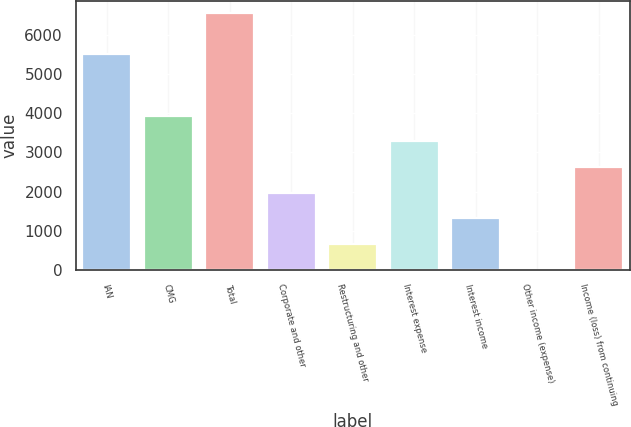Convert chart to OTSL. <chart><loc_0><loc_0><loc_500><loc_500><bar_chart><fcel>IAN<fcel>CMG<fcel>Total<fcel>Corporate and other<fcel>Restructuring and other<fcel>Interest expense<fcel>Interest income<fcel>Other income (expense)<fcel>Income (loss) from continuing<nl><fcel>5505.7<fcel>3935.92<fcel>6554.2<fcel>1972.21<fcel>663.07<fcel>3281.35<fcel>1317.64<fcel>8.5<fcel>2626.78<nl></chart> 